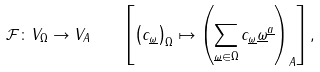Convert formula to latex. <formula><loc_0><loc_0><loc_500><loc_500>\mathcal { F } \colon V _ { \Omega } \to V _ { A } \quad \left [ \left ( c _ { \underline { \omega } } \right ) _ { \Omega } \mapsto \left ( \sum _ { \underline { \omega } \in \Omega } c _ { \underline { \omega } } \underline { \omega } ^ { \underline { a } } \right ) _ { A } \right ] ,</formula> 